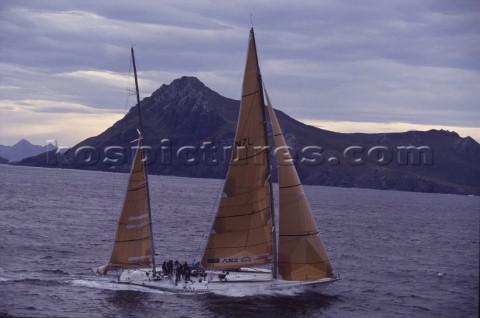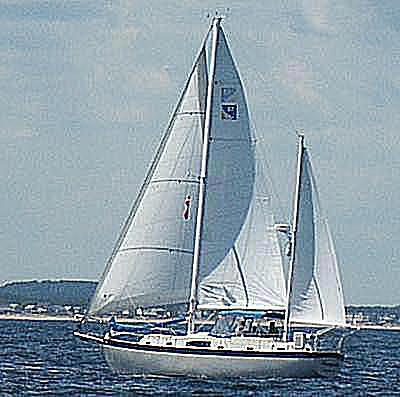The first image is the image on the left, the second image is the image on the right. For the images displayed, is the sentence "There is just one sailboat in one of the images, but the other has at least three sailboats." factually correct? Answer yes or no. No. 